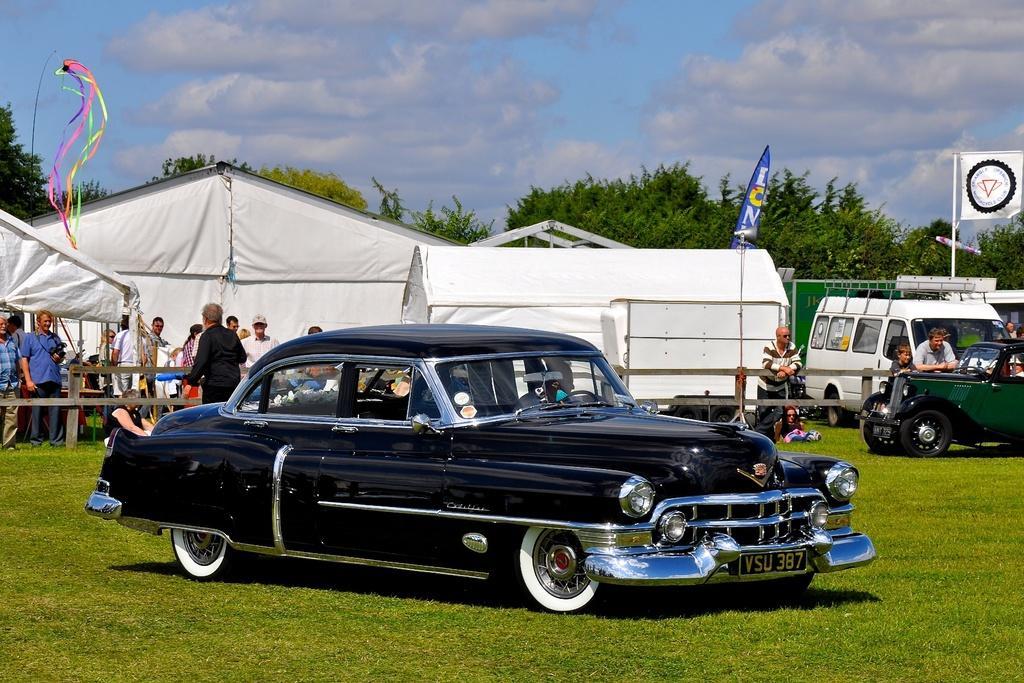Describe this image in one or two sentences. In this image I can see some vehicles on the grass. I can see some people. I can see the tents. In the background, I can see the trees and clouds in the sky. 